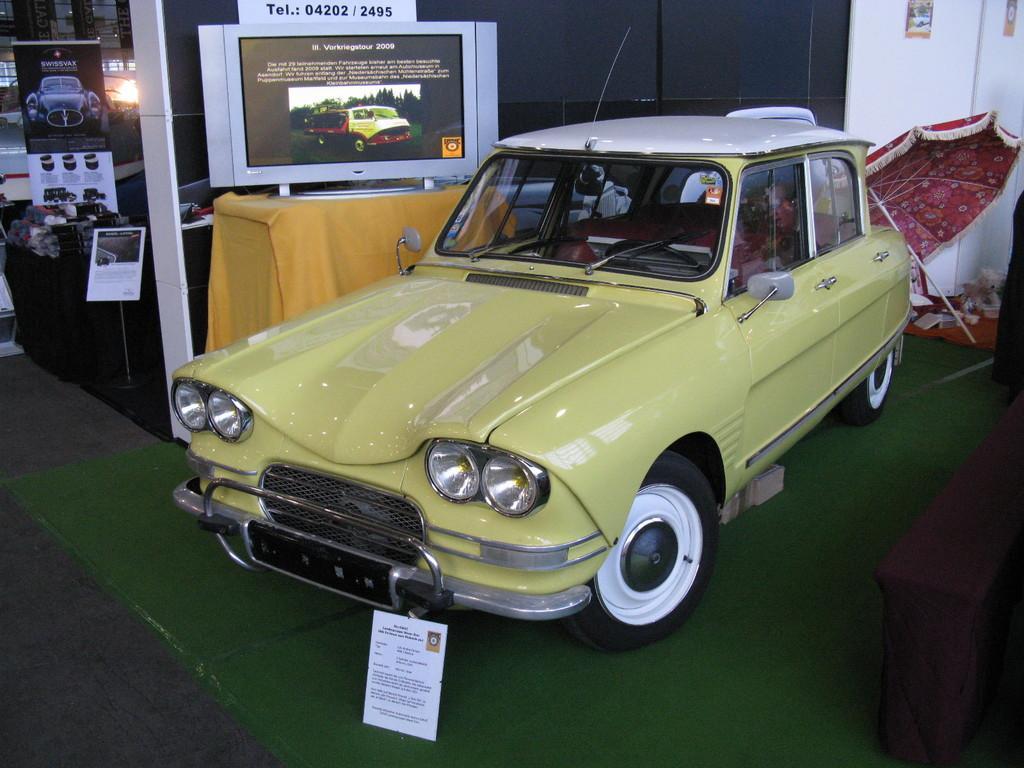Can you describe this image briefly? There is a vehicle parked on the floor which is covered with a carpet near an umbrella and a screen which is on a table. In the background, there are other objects. 